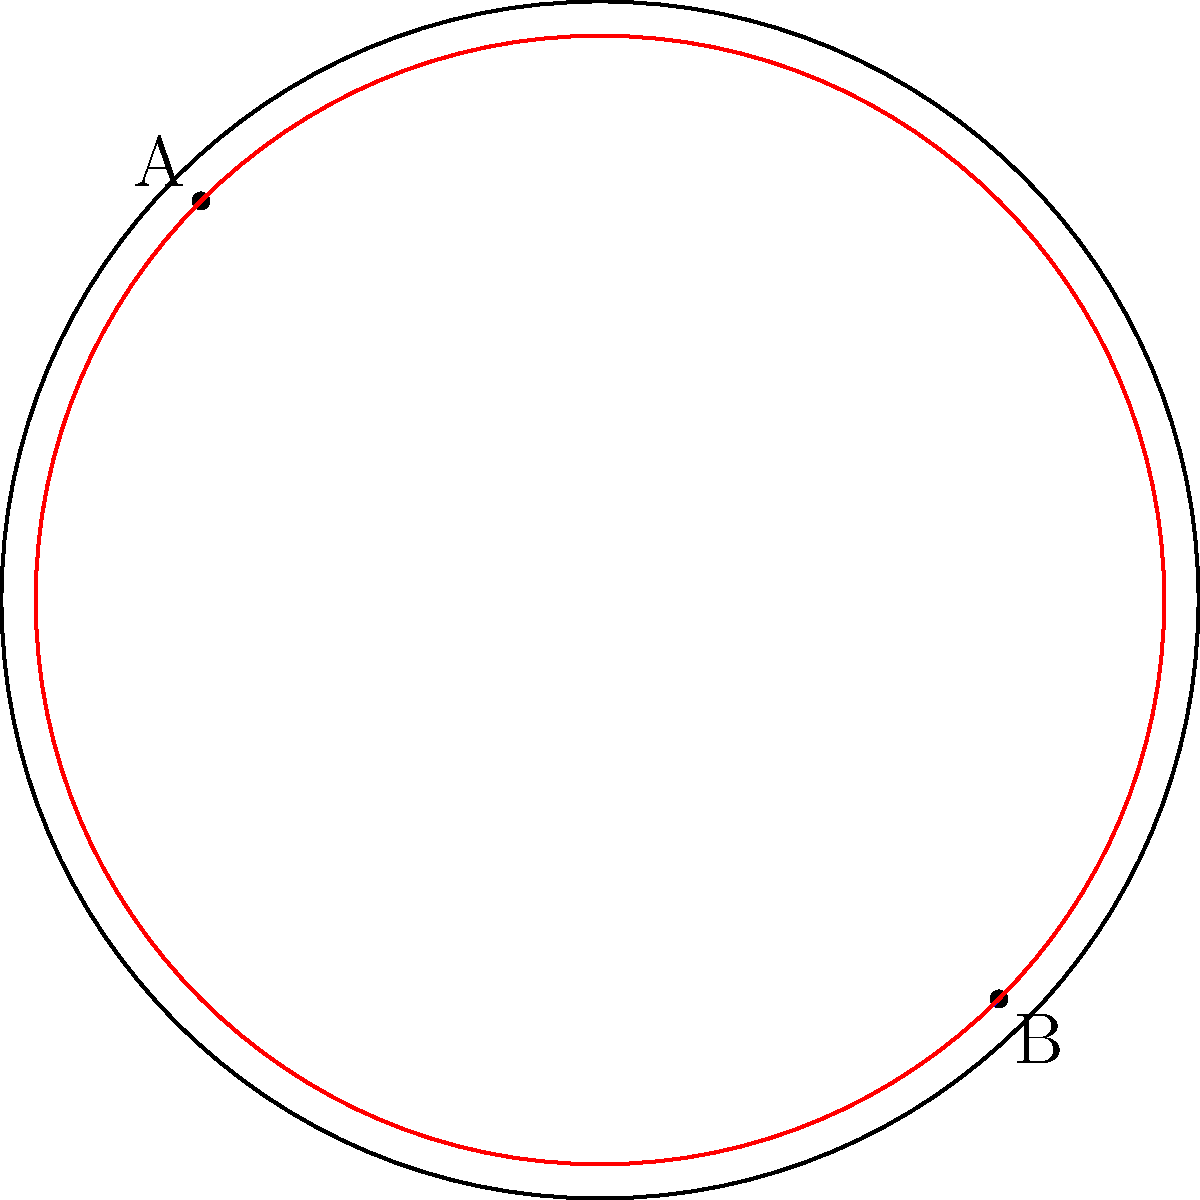On a hyperbolic soccer field represented by the Poincaré disk model, two players are positioned at points A and B. Which path represents the shortest distance between these players: the blue arc or the red arc? To determine the shortest path between two points on a hyperbolic surface represented by the Poincaré disk model, we need to consider the following:

1. In hyperbolic geometry, the shortest path between two points is represented by a geodesic.

2. In the Poincaré disk model, geodesics are represented by either:
   a) Diameters of the disk
   b) Circular arcs that intersect the boundary circle perpendicularly

3. Looking at the diagram:
   - The blue arc is a circular arc that appears to intersect the boundary circle perpendicularly.
   - The red arc is not a diameter and does not intersect the boundary circle perpendicularly.

4. Therefore, the blue arc represents a geodesic in hyperbolic space, while the red arc does not.

5. The shortest path between two points in any geometry is always along a geodesic.

Thus, the blue arc represents the shortest path between players A and B on this hyperbolic soccer field.

This concept is crucial in understanding movement and positioning strategies in a non-Euclidean space, which could offer unique tactical advantages in soccer coaching.
Answer: The blue arc 